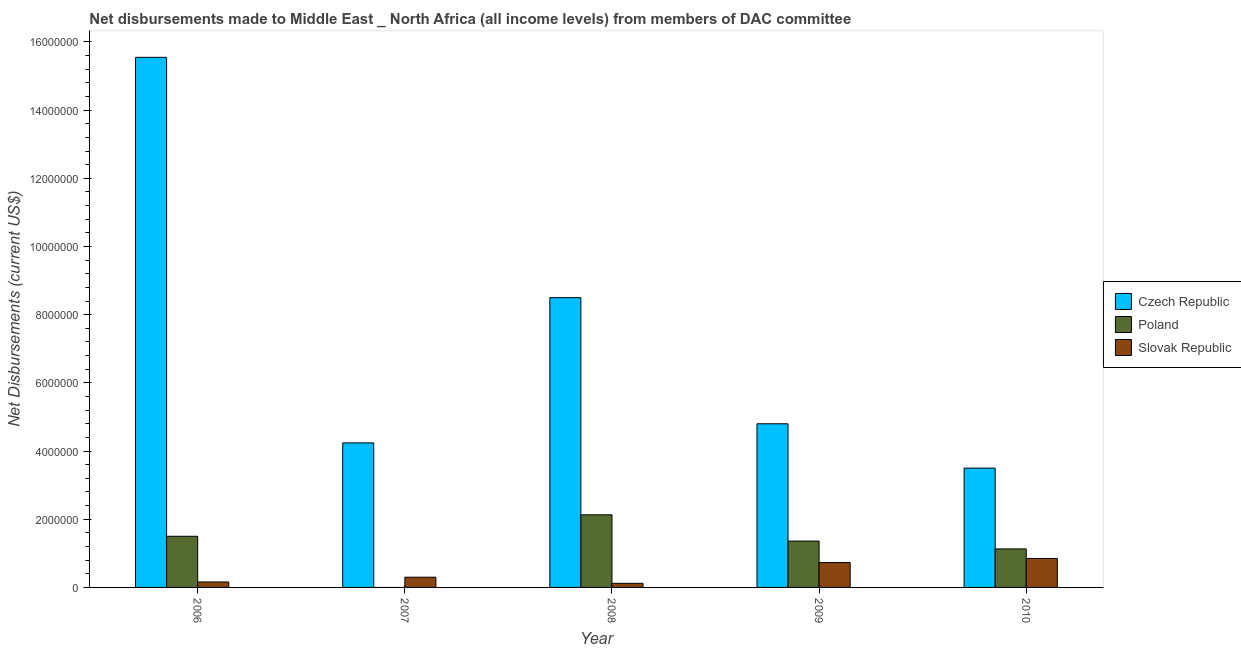In how many cases, is the number of bars for a given year not equal to the number of legend labels?
Make the answer very short. 1. What is the net disbursements made by czech republic in 2010?
Offer a very short reply. 3.50e+06. Across all years, what is the maximum net disbursements made by slovak republic?
Make the answer very short. 8.50e+05. Across all years, what is the minimum net disbursements made by poland?
Your response must be concise. 0. In which year was the net disbursements made by czech republic maximum?
Offer a terse response. 2006. What is the total net disbursements made by slovak republic in the graph?
Your response must be concise. 2.16e+06. What is the difference between the net disbursements made by poland in 2006 and that in 2010?
Make the answer very short. 3.70e+05. What is the difference between the net disbursements made by poland in 2010 and the net disbursements made by czech republic in 2007?
Your answer should be very brief. 1.13e+06. What is the average net disbursements made by poland per year?
Provide a succinct answer. 1.22e+06. In how many years, is the net disbursements made by slovak republic greater than 8400000 US$?
Provide a succinct answer. 0. Is the net disbursements made by slovak republic in 2006 less than that in 2008?
Your answer should be very brief. No. What is the difference between the highest and the second highest net disbursements made by poland?
Your response must be concise. 6.30e+05. What is the difference between the highest and the lowest net disbursements made by poland?
Give a very brief answer. 2.13e+06. How many bars are there?
Give a very brief answer. 14. Are all the bars in the graph horizontal?
Provide a succinct answer. No. Does the graph contain any zero values?
Offer a very short reply. Yes. Where does the legend appear in the graph?
Keep it short and to the point. Center right. How are the legend labels stacked?
Offer a terse response. Vertical. What is the title of the graph?
Provide a succinct answer. Net disbursements made to Middle East _ North Africa (all income levels) from members of DAC committee. Does "Male employers" appear as one of the legend labels in the graph?
Give a very brief answer. No. What is the label or title of the Y-axis?
Your answer should be compact. Net Disbursements (current US$). What is the Net Disbursements (current US$) in Czech Republic in 2006?
Keep it short and to the point. 1.56e+07. What is the Net Disbursements (current US$) in Poland in 2006?
Give a very brief answer. 1.50e+06. What is the Net Disbursements (current US$) of Czech Republic in 2007?
Your answer should be compact. 4.24e+06. What is the Net Disbursements (current US$) in Poland in 2007?
Offer a terse response. 0. What is the Net Disbursements (current US$) of Slovak Republic in 2007?
Keep it short and to the point. 3.00e+05. What is the Net Disbursements (current US$) of Czech Republic in 2008?
Offer a terse response. 8.50e+06. What is the Net Disbursements (current US$) in Poland in 2008?
Offer a very short reply. 2.13e+06. What is the Net Disbursements (current US$) in Slovak Republic in 2008?
Your response must be concise. 1.20e+05. What is the Net Disbursements (current US$) in Czech Republic in 2009?
Offer a very short reply. 4.80e+06. What is the Net Disbursements (current US$) in Poland in 2009?
Ensure brevity in your answer.  1.36e+06. What is the Net Disbursements (current US$) in Slovak Republic in 2009?
Keep it short and to the point. 7.30e+05. What is the Net Disbursements (current US$) in Czech Republic in 2010?
Give a very brief answer. 3.50e+06. What is the Net Disbursements (current US$) of Poland in 2010?
Your answer should be compact. 1.13e+06. What is the Net Disbursements (current US$) of Slovak Republic in 2010?
Offer a terse response. 8.50e+05. Across all years, what is the maximum Net Disbursements (current US$) in Czech Republic?
Keep it short and to the point. 1.56e+07. Across all years, what is the maximum Net Disbursements (current US$) of Poland?
Offer a terse response. 2.13e+06. Across all years, what is the maximum Net Disbursements (current US$) of Slovak Republic?
Ensure brevity in your answer.  8.50e+05. Across all years, what is the minimum Net Disbursements (current US$) in Czech Republic?
Provide a short and direct response. 3.50e+06. What is the total Net Disbursements (current US$) in Czech Republic in the graph?
Offer a very short reply. 3.66e+07. What is the total Net Disbursements (current US$) in Poland in the graph?
Keep it short and to the point. 6.12e+06. What is the total Net Disbursements (current US$) in Slovak Republic in the graph?
Your answer should be very brief. 2.16e+06. What is the difference between the Net Disbursements (current US$) in Czech Republic in 2006 and that in 2007?
Your answer should be very brief. 1.13e+07. What is the difference between the Net Disbursements (current US$) in Czech Republic in 2006 and that in 2008?
Give a very brief answer. 7.05e+06. What is the difference between the Net Disbursements (current US$) of Poland in 2006 and that in 2008?
Provide a succinct answer. -6.30e+05. What is the difference between the Net Disbursements (current US$) of Slovak Republic in 2006 and that in 2008?
Give a very brief answer. 4.00e+04. What is the difference between the Net Disbursements (current US$) of Czech Republic in 2006 and that in 2009?
Ensure brevity in your answer.  1.08e+07. What is the difference between the Net Disbursements (current US$) in Slovak Republic in 2006 and that in 2009?
Give a very brief answer. -5.70e+05. What is the difference between the Net Disbursements (current US$) of Czech Republic in 2006 and that in 2010?
Offer a terse response. 1.20e+07. What is the difference between the Net Disbursements (current US$) in Slovak Republic in 2006 and that in 2010?
Ensure brevity in your answer.  -6.90e+05. What is the difference between the Net Disbursements (current US$) in Czech Republic in 2007 and that in 2008?
Your response must be concise. -4.26e+06. What is the difference between the Net Disbursements (current US$) of Slovak Republic in 2007 and that in 2008?
Ensure brevity in your answer.  1.80e+05. What is the difference between the Net Disbursements (current US$) in Czech Republic in 2007 and that in 2009?
Your answer should be compact. -5.60e+05. What is the difference between the Net Disbursements (current US$) of Slovak Republic in 2007 and that in 2009?
Offer a terse response. -4.30e+05. What is the difference between the Net Disbursements (current US$) in Czech Republic in 2007 and that in 2010?
Offer a terse response. 7.40e+05. What is the difference between the Net Disbursements (current US$) of Slovak Republic in 2007 and that in 2010?
Provide a short and direct response. -5.50e+05. What is the difference between the Net Disbursements (current US$) in Czech Republic in 2008 and that in 2009?
Your response must be concise. 3.70e+06. What is the difference between the Net Disbursements (current US$) of Poland in 2008 and that in 2009?
Ensure brevity in your answer.  7.70e+05. What is the difference between the Net Disbursements (current US$) in Slovak Republic in 2008 and that in 2009?
Your answer should be compact. -6.10e+05. What is the difference between the Net Disbursements (current US$) in Czech Republic in 2008 and that in 2010?
Provide a succinct answer. 5.00e+06. What is the difference between the Net Disbursements (current US$) of Poland in 2008 and that in 2010?
Offer a very short reply. 1.00e+06. What is the difference between the Net Disbursements (current US$) in Slovak Republic in 2008 and that in 2010?
Make the answer very short. -7.30e+05. What is the difference between the Net Disbursements (current US$) in Czech Republic in 2009 and that in 2010?
Your answer should be very brief. 1.30e+06. What is the difference between the Net Disbursements (current US$) in Poland in 2009 and that in 2010?
Ensure brevity in your answer.  2.30e+05. What is the difference between the Net Disbursements (current US$) in Slovak Republic in 2009 and that in 2010?
Ensure brevity in your answer.  -1.20e+05. What is the difference between the Net Disbursements (current US$) of Czech Republic in 2006 and the Net Disbursements (current US$) of Slovak Republic in 2007?
Your answer should be compact. 1.52e+07. What is the difference between the Net Disbursements (current US$) of Poland in 2006 and the Net Disbursements (current US$) of Slovak Republic in 2007?
Offer a very short reply. 1.20e+06. What is the difference between the Net Disbursements (current US$) of Czech Republic in 2006 and the Net Disbursements (current US$) of Poland in 2008?
Provide a short and direct response. 1.34e+07. What is the difference between the Net Disbursements (current US$) of Czech Republic in 2006 and the Net Disbursements (current US$) of Slovak Republic in 2008?
Make the answer very short. 1.54e+07. What is the difference between the Net Disbursements (current US$) in Poland in 2006 and the Net Disbursements (current US$) in Slovak Republic in 2008?
Give a very brief answer. 1.38e+06. What is the difference between the Net Disbursements (current US$) of Czech Republic in 2006 and the Net Disbursements (current US$) of Poland in 2009?
Your answer should be compact. 1.42e+07. What is the difference between the Net Disbursements (current US$) in Czech Republic in 2006 and the Net Disbursements (current US$) in Slovak Republic in 2009?
Your answer should be very brief. 1.48e+07. What is the difference between the Net Disbursements (current US$) in Poland in 2006 and the Net Disbursements (current US$) in Slovak Republic in 2009?
Offer a terse response. 7.70e+05. What is the difference between the Net Disbursements (current US$) of Czech Republic in 2006 and the Net Disbursements (current US$) of Poland in 2010?
Your response must be concise. 1.44e+07. What is the difference between the Net Disbursements (current US$) of Czech Republic in 2006 and the Net Disbursements (current US$) of Slovak Republic in 2010?
Give a very brief answer. 1.47e+07. What is the difference between the Net Disbursements (current US$) of Poland in 2006 and the Net Disbursements (current US$) of Slovak Republic in 2010?
Offer a terse response. 6.50e+05. What is the difference between the Net Disbursements (current US$) in Czech Republic in 2007 and the Net Disbursements (current US$) in Poland in 2008?
Make the answer very short. 2.11e+06. What is the difference between the Net Disbursements (current US$) of Czech Republic in 2007 and the Net Disbursements (current US$) of Slovak Republic in 2008?
Give a very brief answer. 4.12e+06. What is the difference between the Net Disbursements (current US$) in Czech Republic in 2007 and the Net Disbursements (current US$) in Poland in 2009?
Your answer should be very brief. 2.88e+06. What is the difference between the Net Disbursements (current US$) of Czech Republic in 2007 and the Net Disbursements (current US$) of Slovak Republic in 2009?
Offer a terse response. 3.51e+06. What is the difference between the Net Disbursements (current US$) in Czech Republic in 2007 and the Net Disbursements (current US$) in Poland in 2010?
Give a very brief answer. 3.11e+06. What is the difference between the Net Disbursements (current US$) in Czech Republic in 2007 and the Net Disbursements (current US$) in Slovak Republic in 2010?
Give a very brief answer. 3.39e+06. What is the difference between the Net Disbursements (current US$) of Czech Republic in 2008 and the Net Disbursements (current US$) of Poland in 2009?
Provide a short and direct response. 7.14e+06. What is the difference between the Net Disbursements (current US$) in Czech Republic in 2008 and the Net Disbursements (current US$) in Slovak Republic in 2009?
Make the answer very short. 7.77e+06. What is the difference between the Net Disbursements (current US$) in Poland in 2008 and the Net Disbursements (current US$) in Slovak Republic in 2009?
Offer a very short reply. 1.40e+06. What is the difference between the Net Disbursements (current US$) in Czech Republic in 2008 and the Net Disbursements (current US$) in Poland in 2010?
Offer a very short reply. 7.37e+06. What is the difference between the Net Disbursements (current US$) in Czech Republic in 2008 and the Net Disbursements (current US$) in Slovak Republic in 2010?
Provide a short and direct response. 7.65e+06. What is the difference between the Net Disbursements (current US$) in Poland in 2008 and the Net Disbursements (current US$) in Slovak Republic in 2010?
Your response must be concise. 1.28e+06. What is the difference between the Net Disbursements (current US$) of Czech Republic in 2009 and the Net Disbursements (current US$) of Poland in 2010?
Ensure brevity in your answer.  3.67e+06. What is the difference between the Net Disbursements (current US$) in Czech Republic in 2009 and the Net Disbursements (current US$) in Slovak Republic in 2010?
Offer a terse response. 3.95e+06. What is the difference between the Net Disbursements (current US$) of Poland in 2009 and the Net Disbursements (current US$) of Slovak Republic in 2010?
Provide a succinct answer. 5.10e+05. What is the average Net Disbursements (current US$) of Czech Republic per year?
Provide a short and direct response. 7.32e+06. What is the average Net Disbursements (current US$) in Poland per year?
Provide a succinct answer. 1.22e+06. What is the average Net Disbursements (current US$) of Slovak Republic per year?
Provide a succinct answer. 4.32e+05. In the year 2006, what is the difference between the Net Disbursements (current US$) in Czech Republic and Net Disbursements (current US$) in Poland?
Your answer should be very brief. 1.40e+07. In the year 2006, what is the difference between the Net Disbursements (current US$) in Czech Republic and Net Disbursements (current US$) in Slovak Republic?
Provide a short and direct response. 1.54e+07. In the year 2006, what is the difference between the Net Disbursements (current US$) of Poland and Net Disbursements (current US$) of Slovak Republic?
Give a very brief answer. 1.34e+06. In the year 2007, what is the difference between the Net Disbursements (current US$) in Czech Republic and Net Disbursements (current US$) in Slovak Republic?
Your answer should be compact. 3.94e+06. In the year 2008, what is the difference between the Net Disbursements (current US$) of Czech Republic and Net Disbursements (current US$) of Poland?
Your response must be concise. 6.37e+06. In the year 2008, what is the difference between the Net Disbursements (current US$) of Czech Republic and Net Disbursements (current US$) of Slovak Republic?
Offer a terse response. 8.38e+06. In the year 2008, what is the difference between the Net Disbursements (current US$) in Poland and Net Disbursements (current US$) in Slovak Republic?
Provide a succinct answer. 2.01e+06. In the year 2009, what is the difference between the Net Disbursements (current US$) of Czech Republic and Net Disbursements (current US$) of Poland?
Offer a terse response. 3.44e+06. In the year 2009, what is the difference between the Net Disbursements (current US$) in Czech Republic and Net Disbursements (current US$) in Slovak Republic?
Ensure brevity in your answer.  4.07e+06. In the year 2009, what is the difference between the Net Disbursements (current US$) of Poland and Net Disbursements (current US$) of Slovak Republic?
Offer a very short reply. 6.30e+05. In the year 2010, what is the difference between the Net Disbursements (current US$) in Czech Republic and Net Disbursements (current US$) in Poland?
Keep it short and to the point. 2.37e+06. In the year 2010, what is the difference between the Net Disbursements (current US$) in Czech Republic and Net Disbursements (current US$) in Slovak Republic?
Keep it short and to the point. 2.65e+06. In the year 2010, what is the difference between the Net Disbursements (current US$) in Poland and Net Disbursements (current US$) in Slovak Republic?
Keep it short and to the point. 2.80e+05. What is the ratio of the Net Disbursements (current US$) of Czech Republic in 2006 to that in 2007?
Offer a terse response. 3.67. What is the ratio of the Net Disbursements (current US$) of Slovak Republic in 2006 to that in 2007?
Your answer should be very brief. 0.53. What is the ratio of the Net Disbursements (current US$) of Czech Republic in 2006 to that in 2008?
Give a very brief answer. 1.83. What is the ratio of the Net Disbursements (current US$) in Poland in 2006 to that in 2008?
Keep it short and to the point. 0.7. What is the ratio of the Net Disbursements (current US$) in Czech Republic in 2006 to that in 2009?
Your response must be concise. 3.24. What is the ratio of the Net Disbursements (current US$) of Poland in 2006 to that in 2009?
Provide a succinct answer. 1.1. What is the ratio of the Net Disbursements (current US$) in Slovak Republic in 2006 to that in 2009?
Make the answer very short. 0.22. What is the ratio of the Net Disbursements (current US$) of Czech Republic in 2006 to that in 2010?
Offer a terse response. 4.44. What is the ratio of the Net Disbursements (current US$) in Poland in 2006 to that in 2010?
Provide a succinct answer. 1.33. What is the ratio of the Net Disbursements (current US$) of Slovak Republic in 2006 to that in 2010?
Keep it short and to the point. 0.19. What is the ratio of the Net Disbursements (current US$) of Czech Republic in 2007 to that in 2008?
Offer a very short reply. 0.5. What is the ratio of the Net Disbursements (current US$) of Slovak Republic in 2007 to that in 2008?
Make the answer very short. 2.5. What is the ratio of the Net Disbursements (current US$) in Czech Republic in 2007 to that in 2009?
Provide a short and direct response. 0.88. What is the ratio of the Net Disbursements (current US$) of Slovak Republic in 2007 to that in 2009?
Your answer should be compact. 0.41. What is the ratio of the Net Disbursements (current US$) of Czech Republic in 2007 to that in 2010?
Give a very brief answer. 1.21. What is the ratio of the Net Disbursements (current US$) of Slovak Republic in 2007 to that in 2010?
Make the answer very short. 0.35. What is the ratio of the Net Disbursements (current US$) in Czech Republic in 2008 to that in 2009?
Your answer should be compact. 1.77. What is the ratio of the Net Disbursements (current US$) of Poland in 2008 to that in 2009?
Provide a short and direct response. 1.57. What is the ratio of the Net Disbursements (current US$) of Slovak Republic in 2008 to that in 2009?
Your response must be concise. 0.16. What is the ratio of the Net Disbursements (current US$) of Czech Republic in 2008 to that in 2010?
Your answer should be compact. 2.43. What is the ratio of the Net Disbursements (current US$) of Poland in 2008 to that in 2010?
Your answer should be compact. 1.89. What is the ratio of the Net Disbursements (current US$) of Slovak Republic in 2008 to that in 2010?
Give a very brief answer. 0.14. What is the ratio of the Net Disbursements (current US$) in Czech Republic in 2009 to that in 2010?
Provide a short and direct response. 1.37. What is the ratio of the Net Disbursements (current US$) of Poland in 2009 to that in 2010?
Offer a very short reply. 1.2. What is the ratio of the Net Disbursements (current US$) of Slovak Republic in 2009 to that in 2010?
Offer a very short reply. 0.86. What is the difference between the highest and the second highest Net Disbursements (current US$) in Czech Republic?
Provide a succinct answer. 7.05e+06. What is the difference between the highest and the second highest Net Disbursements (current US$) in Poland?
Offer a very short reply. 6.30e+05. What is the difference between the highest and the lowest Net Disbursements (current US$) in Czech Republic?
Provide a short and direct response. 1.20e+07. What is the difference between the highest and the lowest Net Disbursements (current US$) in Poland?
Ensure brevity in your answer.  2.13e+06. What is the difference between the highest and the lowest Net Disbursements (current US$) in Slovak Republic?
Offer a very short reply. 7.30e+05. 